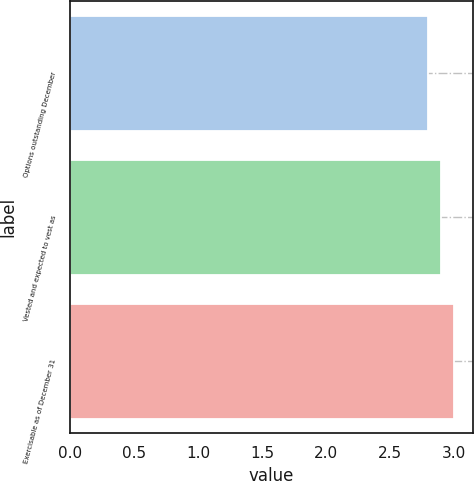Convert chart to OTSL. <chart><loc_0><loc_0><loc_500><loc_500><bar_chart><fcel>Options outstanding December<fcel>Vested and expected to vest as<fcel>Exercisable as of December 31<nl><fcel>2.8<fcel>2.9<fcel>3<nl></chart> 